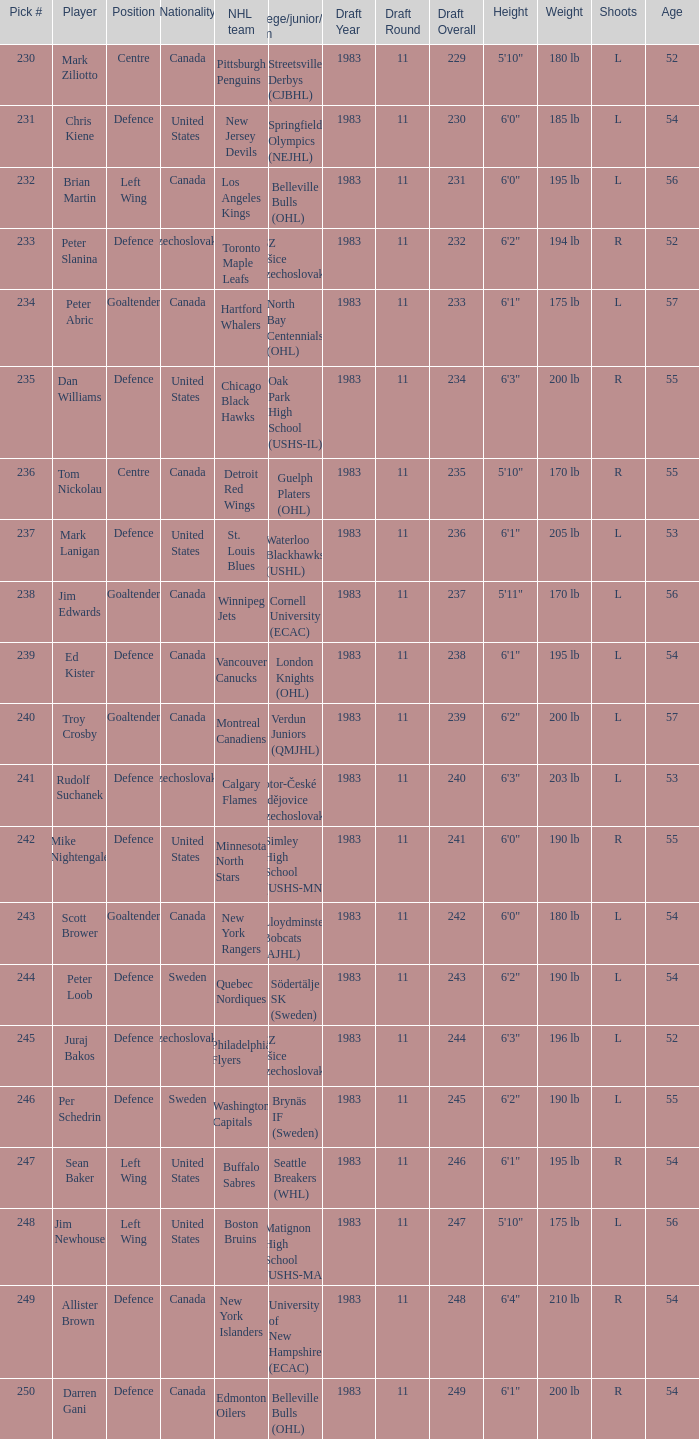Which draft number did the new jersey devils get? 231.0. 